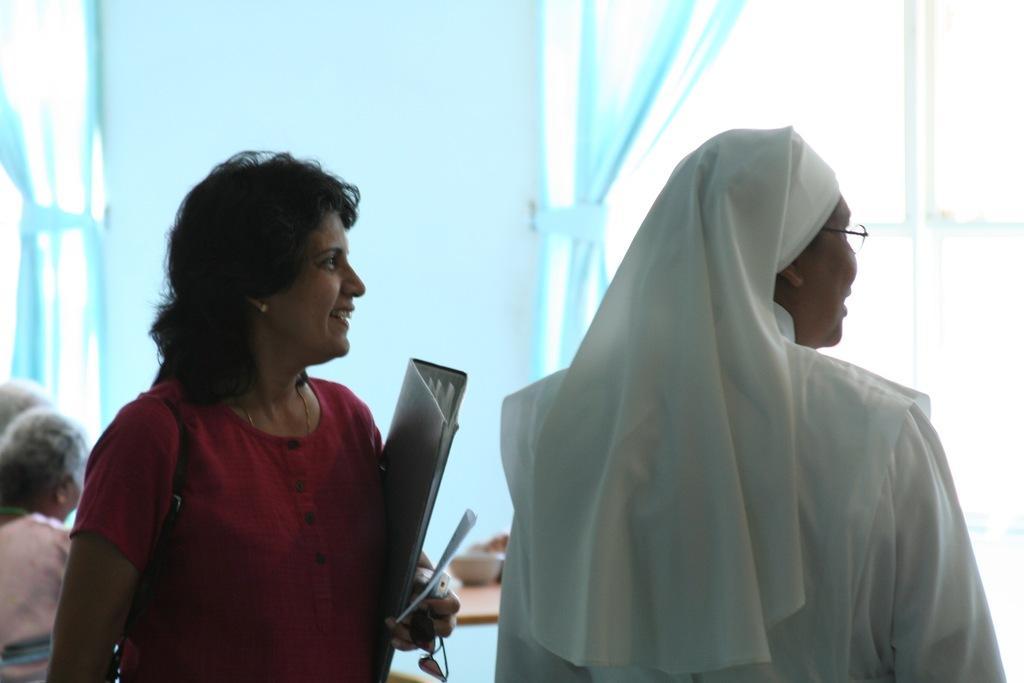Please provide a concise description of this image. This picture seems to be clicked inside. On the right there is a person wearing white color dress. On the left there is a woman wearing red color t-dress, holding some objects and smiling. In the background we can see the curtains and group of persons seems to be sitting and some other objects. 